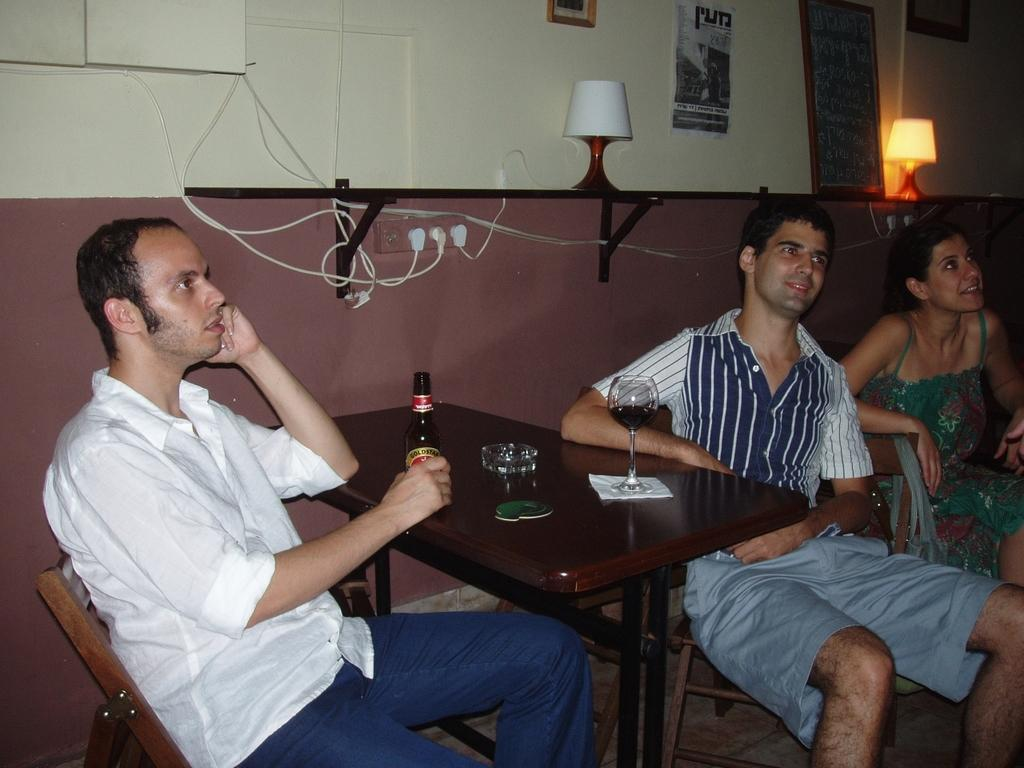How many people are standing on the chair in the image? There are three persons standing on a chair in the image. What is one person holding in the image? One person is holding a bottle in the image. What can be seen in the background of the image? There is a wall in the image. What is providing illumination in the image? There are lights visible in the image. What song is being sung by the person holding the bottle in the image? There is no indication in the image that anyone is singing a song, so it cannot be determined from the picture. 